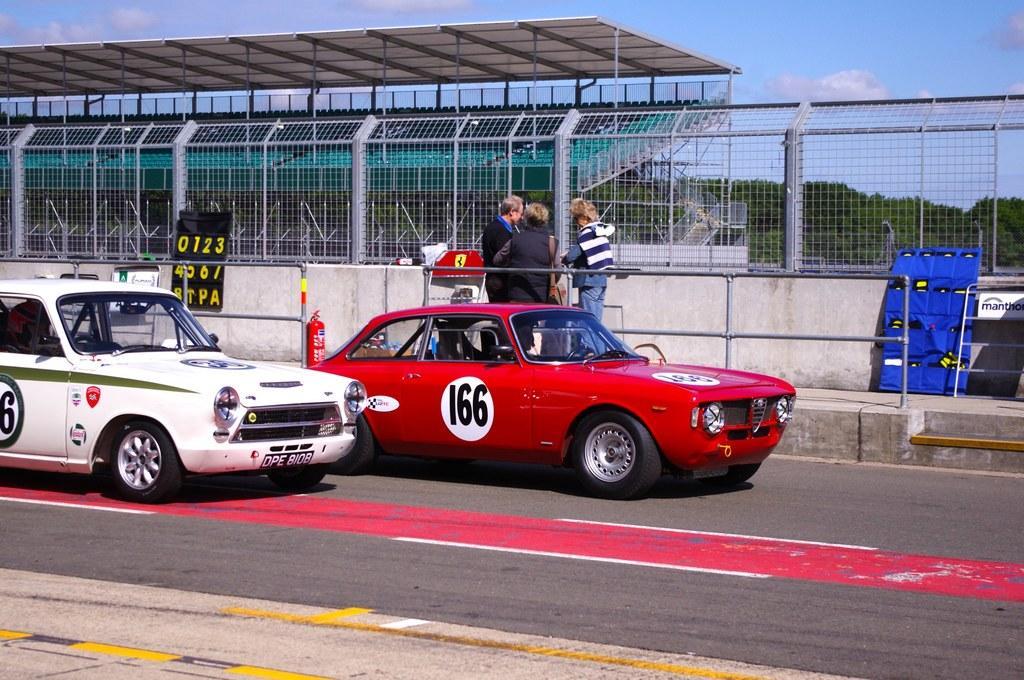Please provide a concise description of this image. In this picture there are two cars on the road. There are group of people standing behind the railing on the footpath. At the back there is a stadium and there are trees. At the top there is sky and there are clouds. There are boards on the footpath. At the bottom there is a road. 